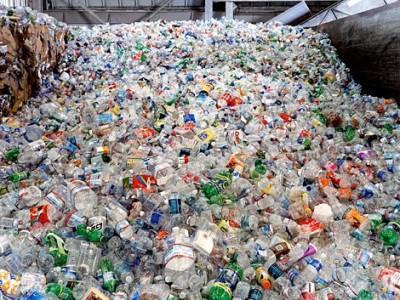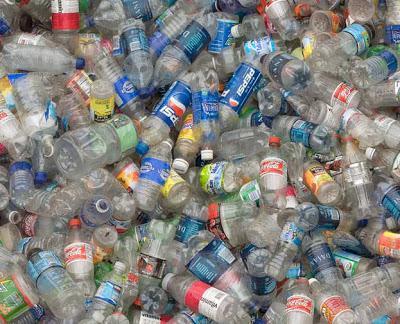The first image is the image on the left, the second image is the image on the right. Examine the images to the left and right. Is the description "At least one image contains small water bottles arranged in neat rows." accurate? Answer yes or no. No. 